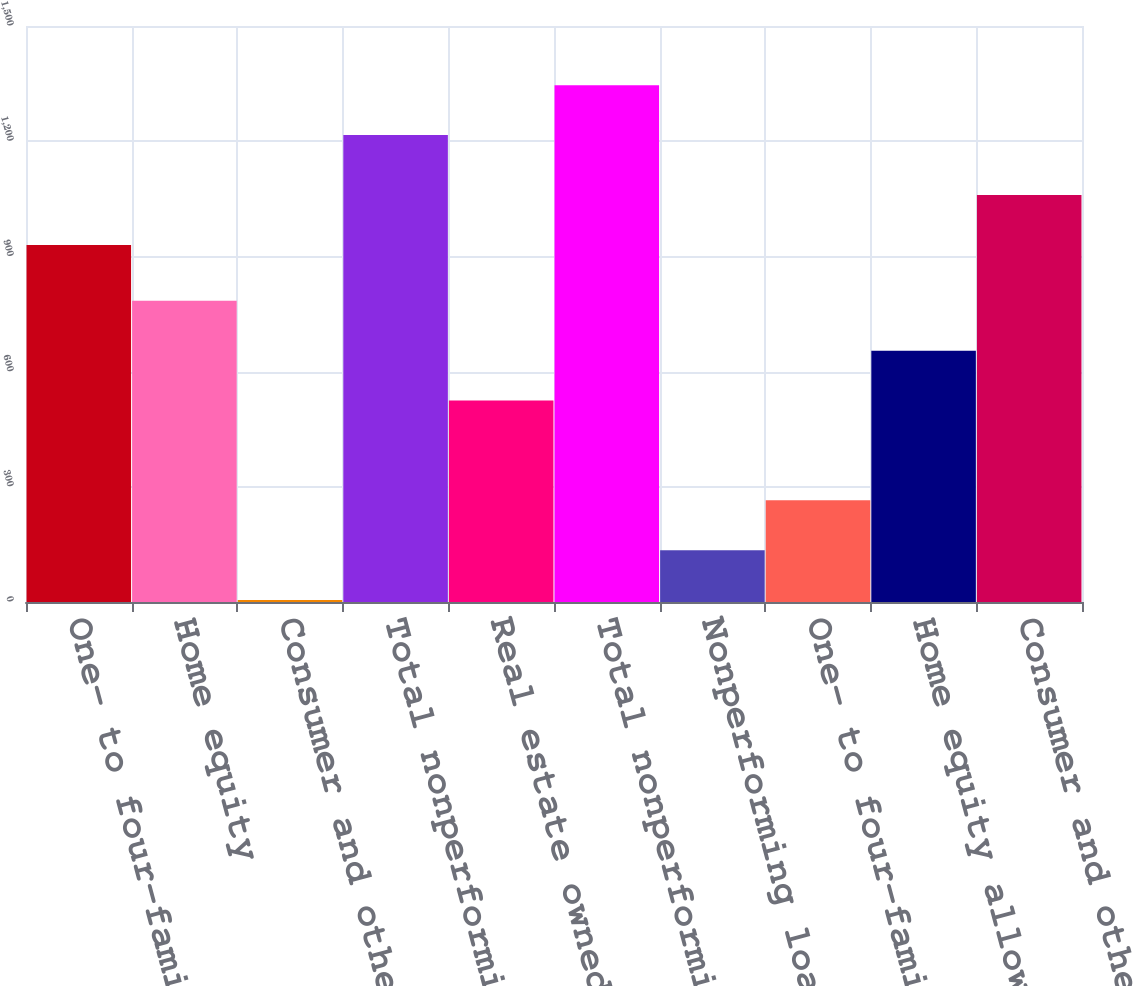Convert chart. <chart><loc_0><loc_0><loc_500><loc_500><bar_chart><fcel>One- to four-family<fcel>Home equity<fcel>Consumer and other<fcel>Total nonperforming loans<fcel>Real estate owned and other<fcel>Total nonperforming assets net<fcel>Nonperforming loans receivable<fcel>One- to four-family allowance<fcel>Home equity allowance for loan<fcel>Consumer and other allowance<nl><fcel>930<fcel>784.4<fcel>5<fcel>1216<fcel>524.6<fcel>1345.9<fcel>134.9<fcel>264.8<fcel>654.5<fcel>1059.9<nl></chart> 